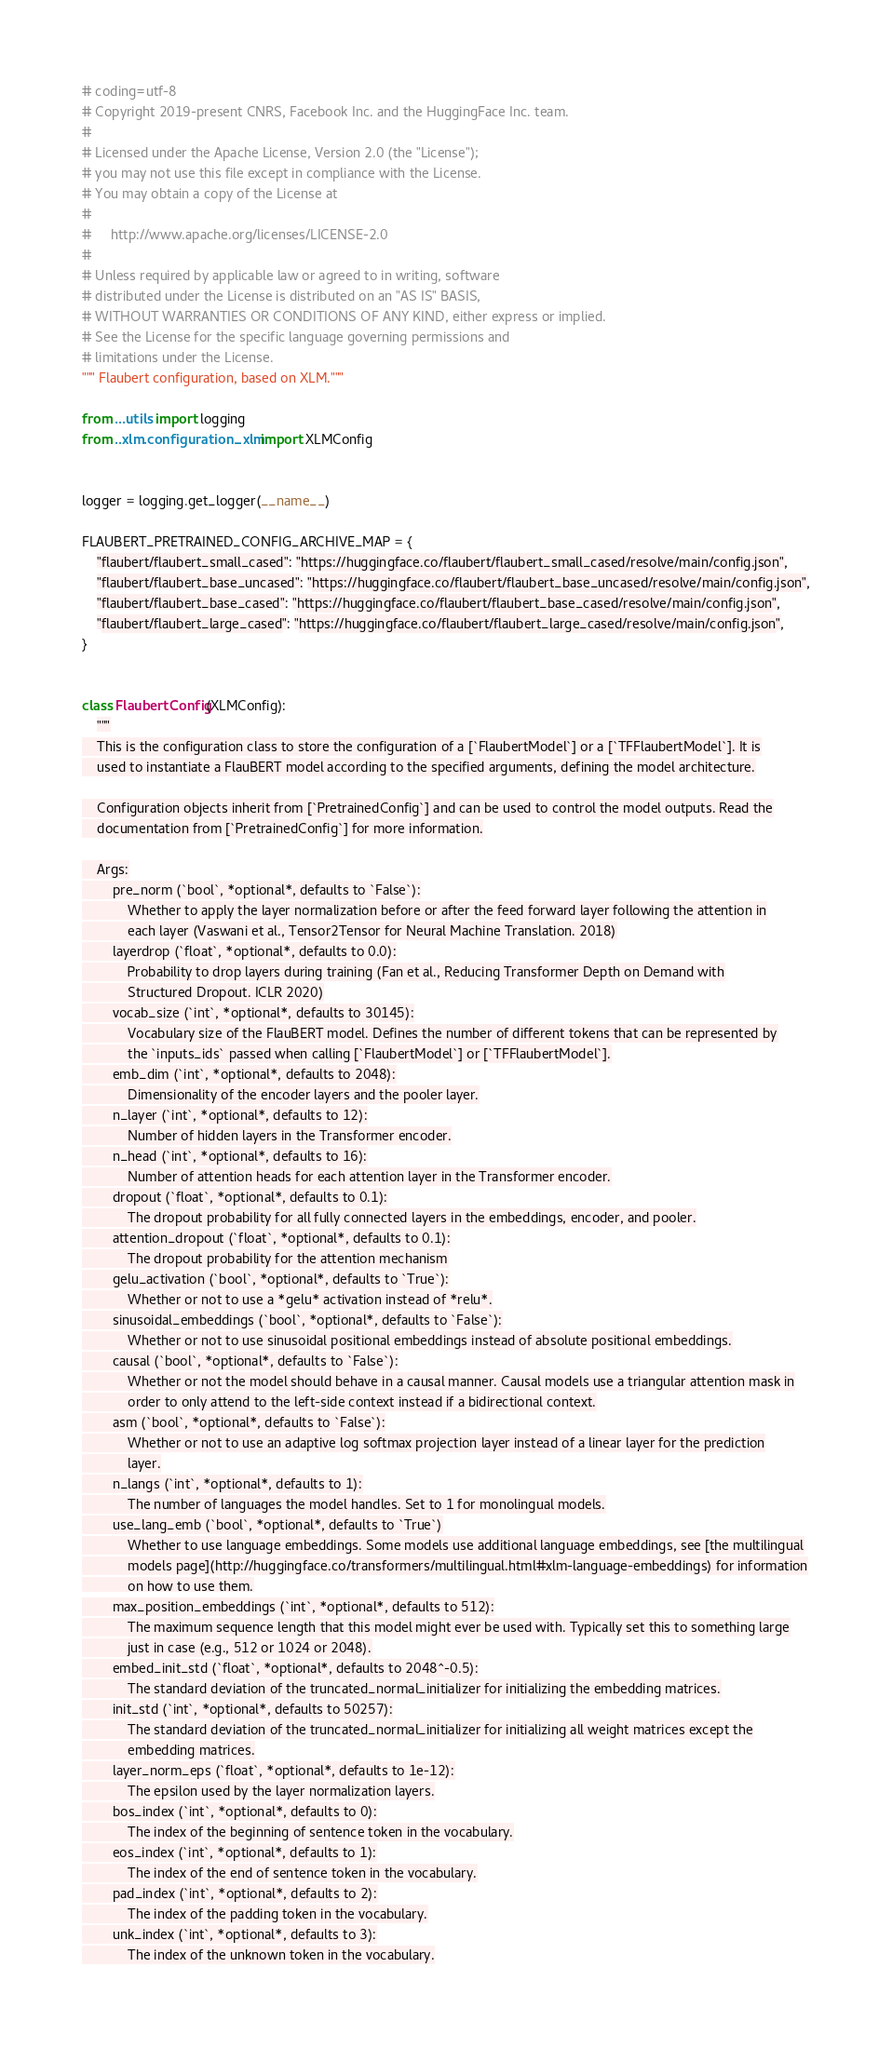Convert code to text. <code><loc_0><loc_0><loc_500><loc_500><_Python_># coding=utf-8
# Copyright 2019-present CNRS, Facebook Inc. and the HuggingFace Inc. team.
#
# Licensed under the Apache License, Version 2.0 (the "License");
# you may not use this file except in compliance with the License.
# You may obtain a copy of the License at
#
#     http://www.apache.org/licenses/LICENSE-2.0
#
# Unless required by applicable law or agreed to in writing, software
# distributed under the License is distributed on an "AS IS" BASIS,
# WITHOUT WARRANTIES OR CONDITIONS OF ANY KIND, either express or implied.
# See the License for the specific language governing permissions and
# limitations under the License.
""" Flaubert configuration, based on XLM."""

from ...utils import logging
from ..xlm.configuration_xlm import XLMConfig


logger = logging.get_logger(__name__)

FLAUBERT_PRETRAINED_CONFIG_ARCHIVE_MAP = {
    "flaubert/flaubert_small_cased": "https://huggingface.co/flaubert/flaubert_small_cased/resolve/main/config.json",
    "flaubert/flaubert_base_uncased": "https://huggingface.co/flaubert/flaubert_base_uncased/resolve/main/config.json",
    "flaubert/flaubert_base_cased": "https://huggingface.co/flaubert/flaubert_base_cased/resolve/main/config.json",
    "flaubert/flaubert_large_cased": "https://huggingface.co/flaubert/flaubert_large_cased/resolve/main/config.json",
}


class FlaubertConfig(XLMConfig):
    """
    This is the configuration class to store the configuration of a [`FlaubertModel`] or a [`TFFlaubertModel`]. It is
    used to instantiate a FlauBERT model according to the specified arguments, defining the model architecture.

    Configuration objects inherit from [`PretrainedConfig`] and can be used to control the model outputs. Read the
    documentation from [`PretrainedConfig`] for more information.

    Args:
        pre_norm (`bool`, *optional*, defaults to `False`):
            Whether to apply the layer normalization before or after the feed forward layer following the attention in
            each layer (Vaswani et al., Tensor2Tensor for Neural Machine Translation. 2018)
        layerdrop (`float`, *optional*, defaults to 0.0):
            Probability to drop layers during training (Fan et al., Reducing Transformer Depth on Demand with
            Structured Dropout. ICLR 2020)
        vocab_size (`int`, *optional*, defaults to 30145):
            Vocabulary size of the FlauBERT model. Defines the number of different tokens that can be represented by
            the `inputs_ids` passed when calling [`FlaubertModel`] or [`TFFlaubertModel`].
        emb_dim (`int`, *optional*, defaults to 2048):
            Dimensionality of the encoder layers and the pooler layer.
        n_layer (`int`, *optional*, defaults to 12):
            Number of hidden layers in the Transformer encoder.
        n_head (`int`, *optional*, defaults to 16):
            Number of attention heads for each attention layer in the Transformer encoder.
        dropout (`float`, *optional*, defaults to 0.1):
            The dropout probability for all fully connected layers in the embeddings, encoder, and pooler.
        attention_dropout (`float`, *optional*, defaults to 0.1):
            The dropout probability for the attention mechanism
        gelu_activation (`bool`, *optional*, defaults to `True`):
            Whether or not to use a *gelu* activation instead of *relu*.
        sinusoidal_embeddings (`bool`, *optional*, defaults to `False`):
            Whether or not to use sinusoidal positional embeddings instead of absolute positional embeddings.
        causal (`bool`, *optional*, defaults to `False`):
            Whether or not the model should behave in a causal manner. Causal models use a triangular attention mask in
            order to only attend to the left-side context instead if a bidirectional context.
        asm (`bool`, *optional*, defaults to `False`):
            Whether or not to use an adaptive log softmax projection layer instead of a linear layer for the prediction
            layer.
        n_langs (`int`, *optional*, defaults to 1):
            The number of languages the model handles. Set to 1 for monolingual models.
        use_lang_emb (`bool`, *optional*, defaults to `True`)
            Whether to use language embeddings. Some models use additional language embeddings, see [the multilingual
            models page](http://huggingface.co/transformers/multilingual.html#xlm-language-embeddings) for information
            on how to use them.
        max_position_embeddings (`int`, *optional*, defaults to 512):
            The maximum sequence length that this model might ever be used with. Typically set this to something large
            just in case (e.g., 512 or 1024 or 2048).
        embed_init_std (`float`, *optional*, defaults to 2048^-0.5):
            The standard deviation of the truncated_normal_initializer for initializing the embedding matrices.
        init_std (`int`, *optional*, defaults to 50257):
            The standard deviation of the truncated_normal_initializer for initializing all weight matrices except the
            embedding matrices.
        layer_norm_eps (`float`, *optional*, defaults to 1e-12):
            The epsilon used by the layer normalization layers.
        bos_index (`int`, *optional*, defaults to 0):
            The index of the beginning of sentence token in the vocabulary.
        eos_index (`int`, *optional*, defaults to 1):
            The index of the end of sentence token in the vocabulary.
        pad_index (`int`, *optional*, defaults to 2):
            The index of the padding token in the vocabulary.
        unk_index (`int`, *optional*, defaults to 3):
            The index of the unknown token in the vocabulary.</code> 